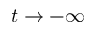Convert formula to latex. <formula><loc_0><loc_0><loc_500><loc_500>t \to - \infty</formula> 